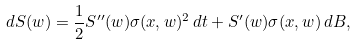Convert formula to latex. <formula><loc_0><loc_0><loc_500><loc_500>d S ( w ) = \frac { 1 } { 2 } S ^ { \prime \prime } ( w ) \sigma ( x , w ) ^ { 2 } \, d t + S ^ { \prime } ( w ) \sigma ( x , w ) \, d B ,</formula> 